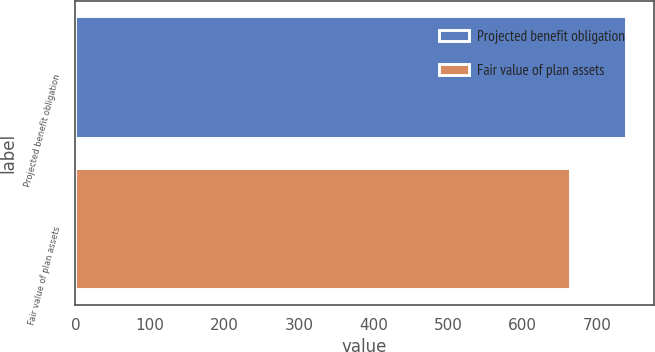Convert chart to OTSL. <chart><loc_0><loc_0><loc_500><loc_500><bar_chart><fcel>Projected benefit obligation<fcel>Fair value of plan assets<nl><fcel>739<fcel>663<nl></chart> 